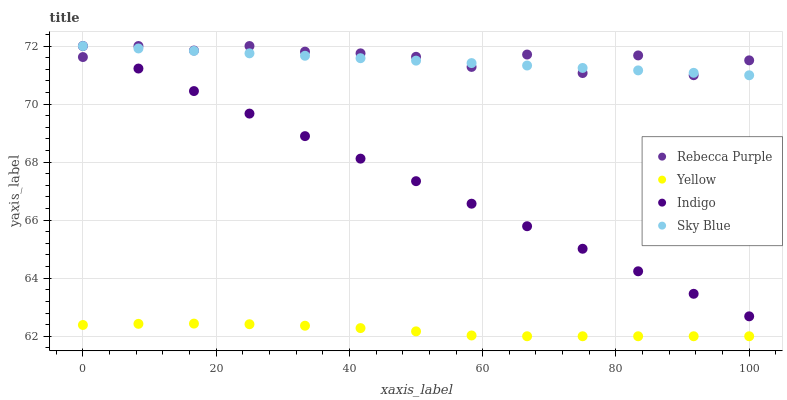Does Yellow have the minimum area under the curve?
Answer yes or no. Yes. Does Rebecca Purple have the maximum area under the curve?
Answer yes or no. Yes. Does Indigo have the minimum area under the curve?
Answer yes or no. No. Does Indigo have the maximum area under the curve?
Answer yes or no. No. Is Sky Blue the smoothest?
Answer yes or no. Yes. Is Rebecca Purple the roughest?
Answer yes or no. Yes. Is Indigo the smoothest?
Answer yes or no. No. Is Indigo the roughest?
Answer yes or no. No. Does Yellow have the lowest value?
Answer yes or no. Yes. Does Indigo have the lowest value?
Answer yes or no. No. Does Rebecca Purple have the highest value?
Answer yes or no. Yes. Does Yellow have the highest value?
Answer yes or no. No. Is Yellow less than Rebecca Purple?
Answer yes or no. Yes. Is Rebecca Purple greater than Yellow?
Answer yes or no. Yes. Does Indigo intersect Rebecca Purple?
Answer yes or no. Yes. Is Indigo less than Rebecca Purple?
Answer yes or no. No. Is Indigo greater than Rebecca Purple?
Answer yes or no. No. Does Yellow intersect Rebecca Purple?
Answer yes or no. No. 